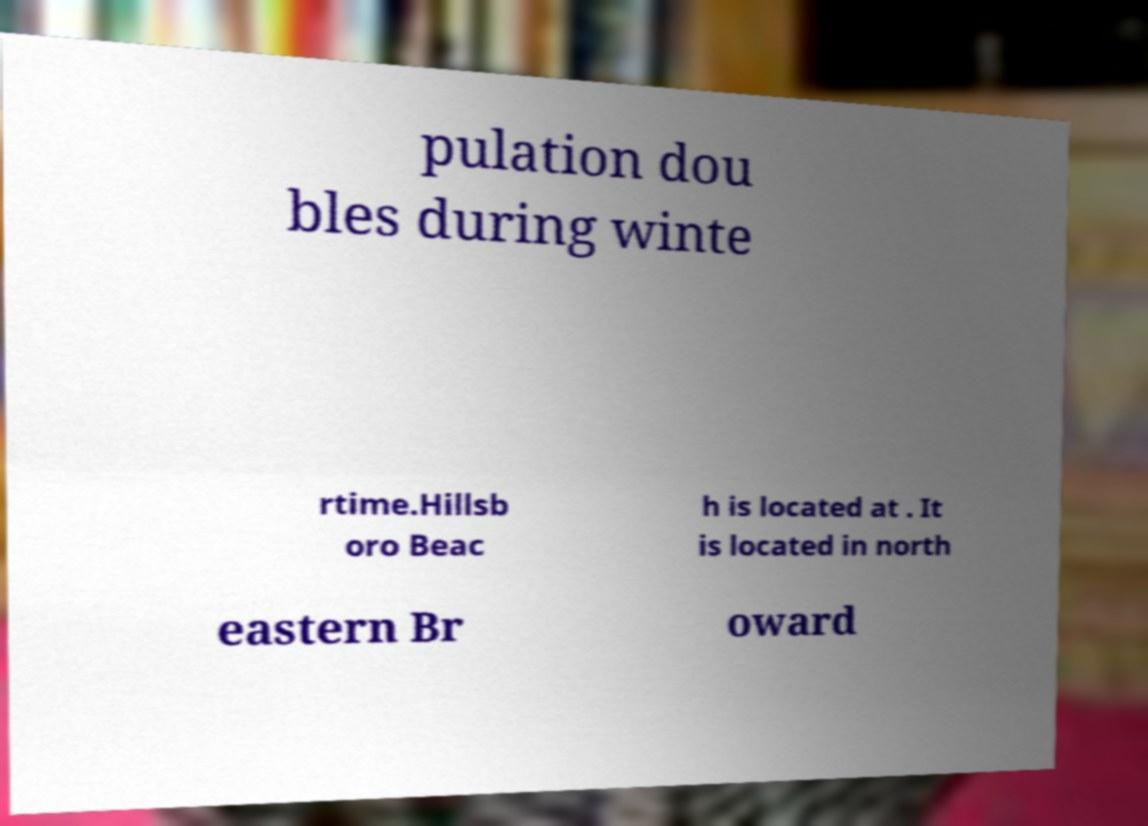Can you accurately transcribe the text from the provided image for me? pulation dou bles during winte rtime.Hillsb oro Beac h is located at . It is located in north eastern Br oward 